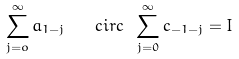Convert formula to latex. <formula><loc_0><loc_0><loc_500><loc_500>\sum _ { j = o } ^ { \infty } a _ { 1 - j } \quad c i r c \ \sum _ { j = 0 } ^ { \infty } c _ { - 1 - j } = I</formula> 